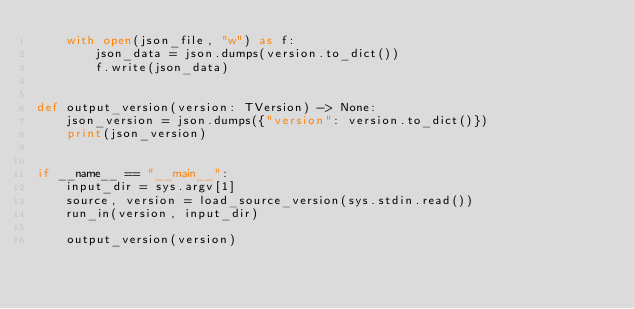<code> <loc_0><loc_0><loc_500><loc_500><_Python_>    with open(json_file, "w") as f:
        json_data = json.dumps(version.to_dict())
        f.write(json_data)


def output_version(version: TVersion) -> None:
    json_version = json.dumps({"version": version.to_dict()})
    print(json_version)


if __name__ == "__main__":
    input_dir = sys.argv[1]
    source, version = load_source_version(sys.stdin.read())
    run_in(version, input_dir)

    output_version(version)
</code> 